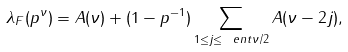Convert formula to latex. <formula><loc_0><loc_0><loc_500><loc_500>\lambda _ { F } ( p ^ { \nu } ) = A ( \nu ) + ( 1 - p ^ { - 1 } ) \sum _ { 1 \leq j \leq \ e n t { \nu / 2 } } A ( \nu - 2 j ) ,</formula> 